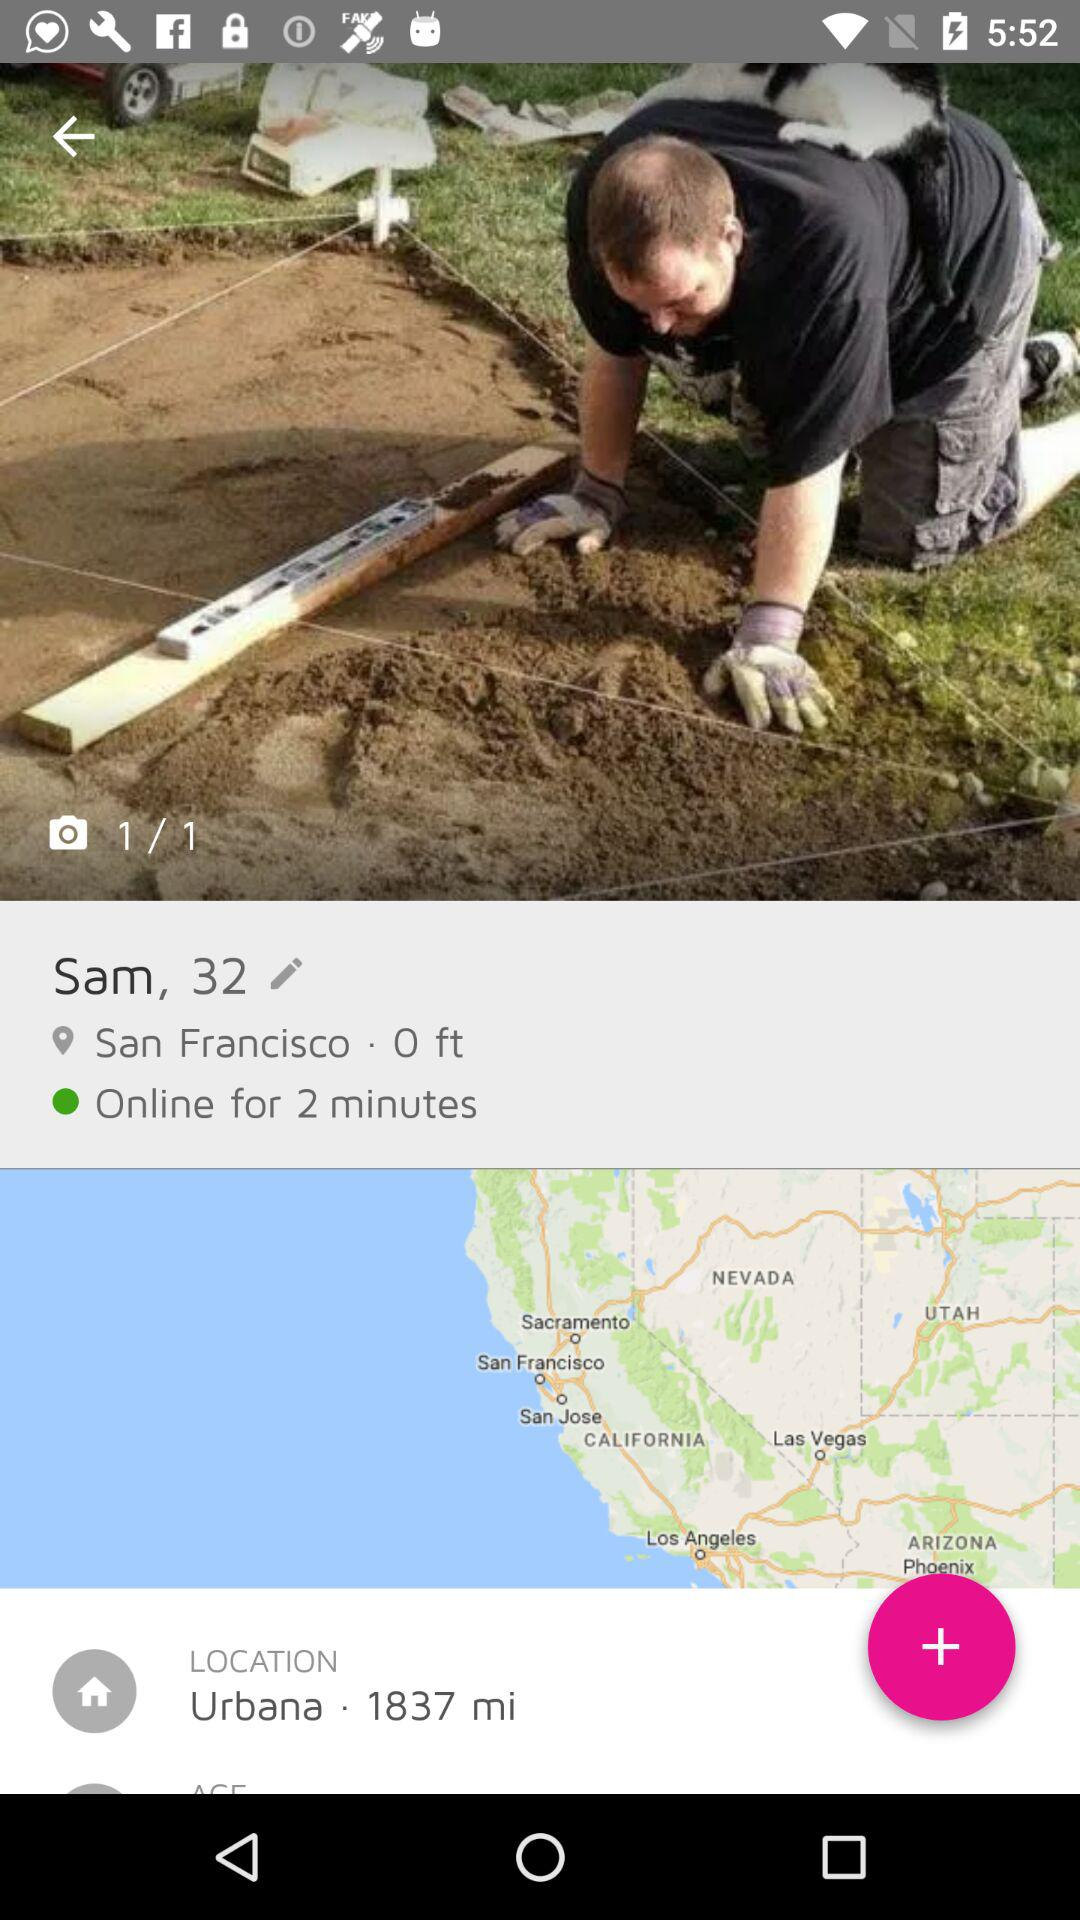For how long has Sam been online? Sam has been online for 2 minutes. 